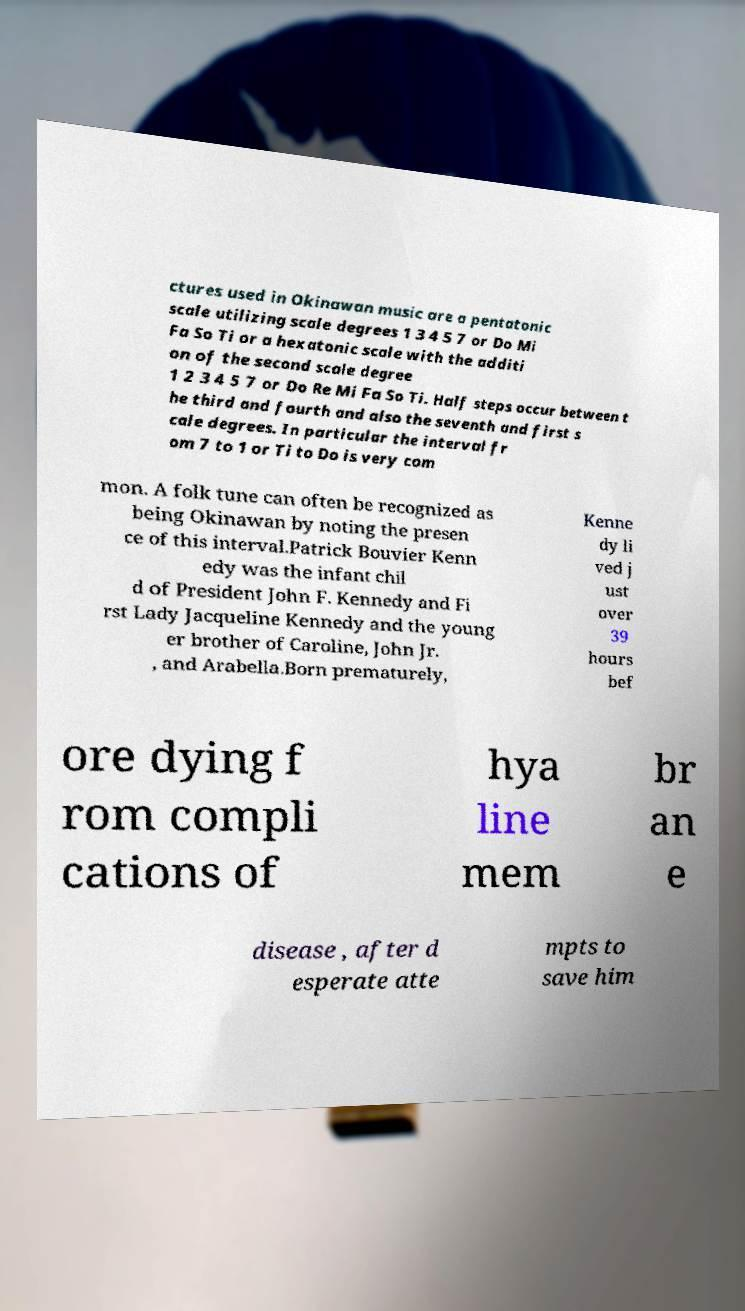Please identify and transcribe the text found in this image. ctures used in Okinawan music are a pentatonic scale utilizing scale degrees 1 3 4 5 7 or Do Mi Fa So Ti or a hexatonic scale with the additi on of the second scale degree 1 2 3 4 5 7 or Do Re Mi Fa So Ti. Half steps occur between t he third and fourth and also the seventh and first s cale degrees. In particular the interval fr om 7 to 1 or Ti to Do is very com mon. A folk tune can often be recognized as being Okinawan by noting the presen ce of this interval.Patrick Bouvier Kenn edy was the infant chil d of President John F. Kennedy and Fi rst Lady Jacqueline Kennedy and the young er brother of Caroline, John Jr. , and Arabella.Born prematurely, Kenne dy li ved j ust over 39 hours bef ore dying f rom compli cations of hya line mem br an e disease , after d esperate atte mpts to save him 